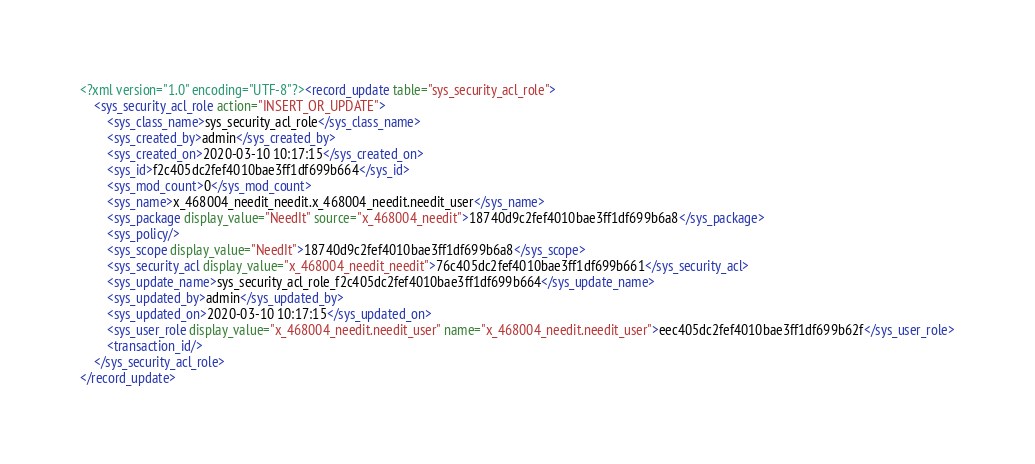Convert code to text. <code><loc_0><loc_0><loc_500><loc_500><_XML_><?xml version="1.0" encoding="UTF-8"?><record_update table="sys_security_acl_role">
    <sys_security_acl_role action="INSERT_OR_UPDATE">
        <sys_class_name>sys_security_acl_role</sys_class_name>
        <sys_created_by>admin</sys_created_by>
        <sys_created_on>2020-03-10 10:17:15</sys_created_on>
        <sys_id>f2c405dc2fef4010bae3ff1df699b664</sys_id>
        <sys_mod_count>0</sys_mod_count>
        <sys_name>x_468004_needit_needit.x_468004_needit.needit_user</sys_name>
        <sys_package display_value="NeedIt" source="x_468004_needit">18740d9c2fef4010bae3ff1df699b6a8</sys_package>
        <sys_policy/>
        <sys_scope display_value="NeedIt">18740d9c2fef4010bae3ff1df699b6a8</sys_scope>
        <sys_security_acl display_value="x_468004_needit_needit">76c405dc2fef4010bae3ff1df699b661</sys_security_acl>
        <sys_update_name>sys_security_acl_role_f2c405dc2fef4010bae3ff1df699b664</sys_update_name>
        <sys_updated_by>admin</sys_updated_by>
        <sys_updated_on>2020-03-10 10:17:15</sys_updated_on>
        <sys_user_role display_value="x_468004_needit.needit_user" name="x_468004_needit.needit_user">eec405dc2fef4010bae3ff1df699b62f</sys_user_role>
        <transaction_id/>
    </sys_security_acl_role>
</record_update>
</code> 